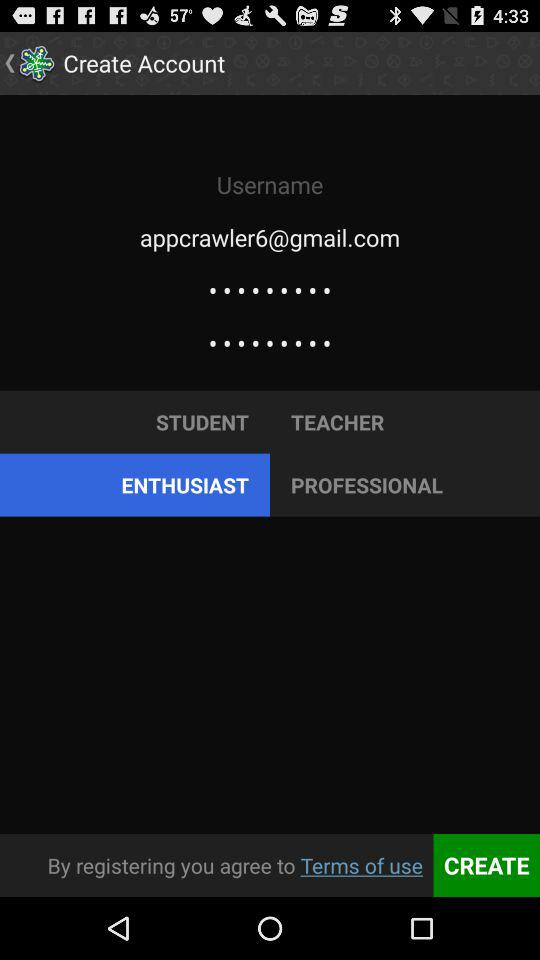Which option is selected? The selected option is "ENTHUSIAST". 